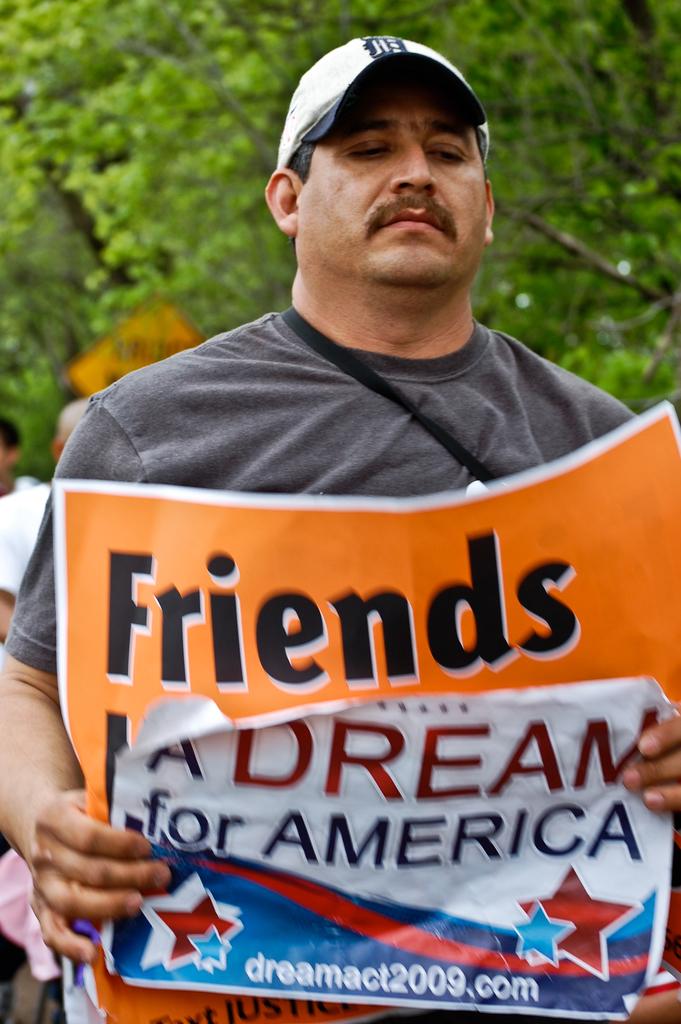Who is the dream for?
Provide a succinct answer. America. What is written under the orange friends sign?
Give a very brief answer. A dream for america. 